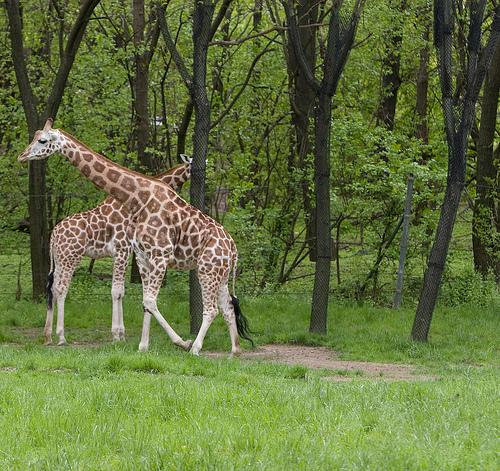Why is one giraffe smaller than the other?
Keep it brief. Distance. What kind of animal is this?
Short answer required. Giraffe. Is the left leg of the giraffe on the left bent at more than 90 degrees?
Keep it brief. No. Are these animals standing up?
Short answer required. Yes. Where are the two zebras in the picture?
Concise answer only. Nowhere. How many giraffes in this photo?
Be succinct. 2. What is the giraffe on the right doing to the giraffe on the left?
Concise answer only. Nothing. How many giraffes?
Concise answer only. 2. Is this a zoo setting?
Keep it brief. No. How many animals are there?
Concise answer only. 2. How many animals are in the picture?
Give a very brief answer. 2. Where are the giraffes?
Give a very brief answer. Forest. 